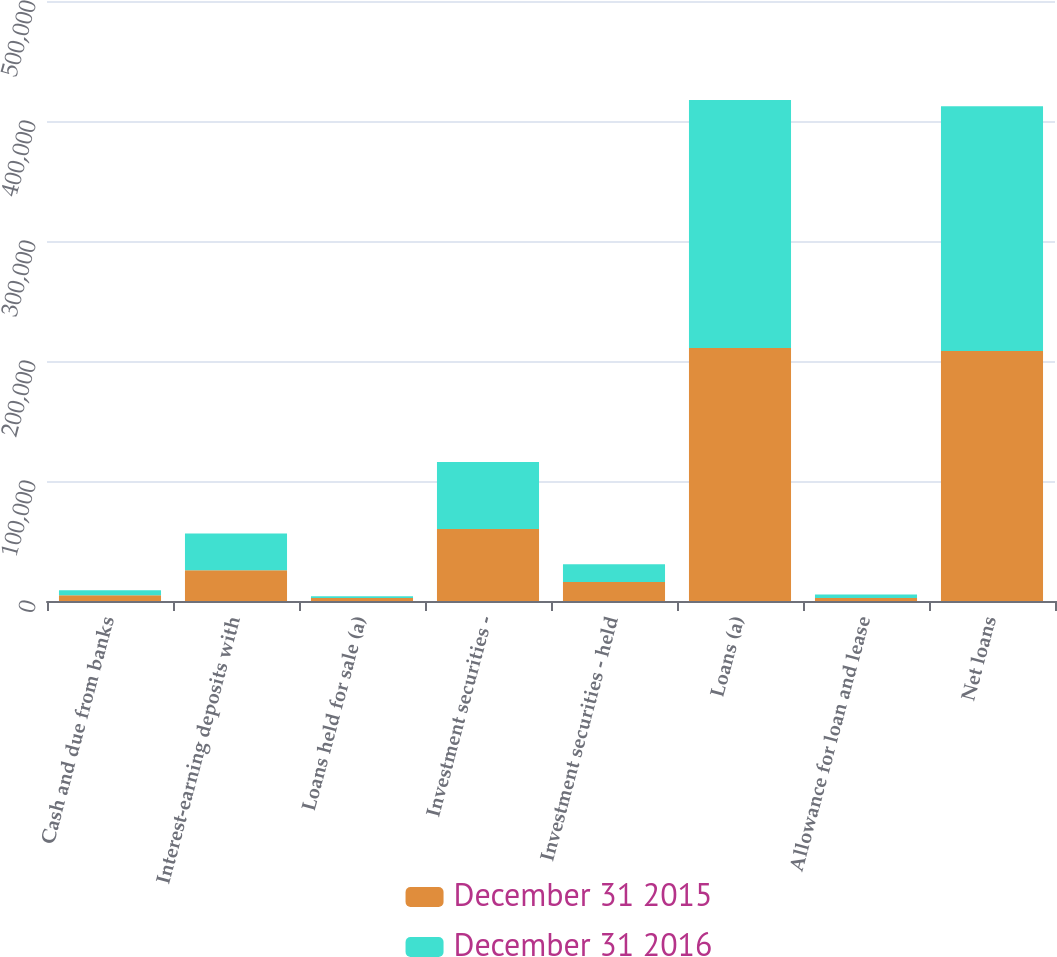Convert chart. <chart><loc_0><loc_0><loc_500><loc_500><stacked_bar_chart><ecel><fcel>Cash and due from banks<fcel>Interest-earning deposits with<fcel>Loans held for sale (a)<fcel>Investment securities -<fcel>Investment securities - held<fcel>Loans (a)<fcel>Allowance for loan and lease<fcel>Net loans<nl><fcel>December 31 2015<fcel>4879<fcel>25711<fcel>2504<fcel>60104<fcel>15843<fcel>210833<fcel>2589<fcel>208244<nl><fcel>December 31 2016<fcel>4065<fcel>30546<fcel>1540<fcel>55760<fcel>14768<fcel>206696<fcel>2727<fcel>203969<nl></chart> 